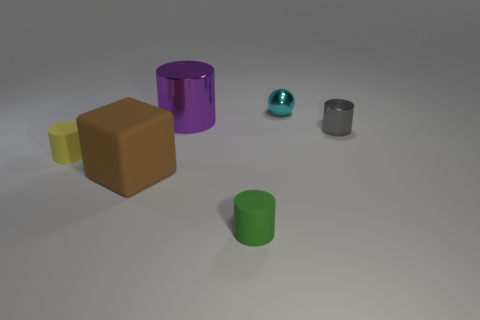The large cylinder that is to the right of the rubber cylinder that is behind the small matte cylinder in front of the yellow thing is made of what material?
Make the answer very short. Metal. Are there any blue cylinders that have the same size as the cyan metal thing?
Your response must be concise. No. There is a green cylinder that is the same size as the cyan metallic sphere; what is its material?
Offer a very short reply. Rubber. There is a big object behind the tiny gray thing; what is its shape?
Offer a very short reply. Cylinder. Do the big object behind the yellow thing and the big object that is in front of the big metallic thing have the same material?
Your answer should be very brief. No. What number of tiny cyan metal things are the same shape as the big purple metal object?
Your answer should be very brief. 0. How many things are either green cylinders or tiny things in front of the big purple metal thing?
Make the answer very short. 3. What is the material of the green thing?
Your response must be concise. Rubber. What material is the gray thing that is the same shape as the yellow thing?
Your response must be concise. Metal. The rubber thing behind the brown thing that is on the left side of the tiny cyan shiny object is what color?
Keep it short and to the point. Yellow. 